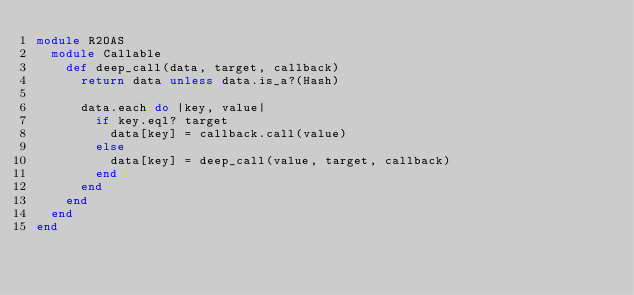Convert code to text. <code><loc_0><loc_0><loc_500><loc_500><_Ruby_>module R2OAS
  module Callable
    def deep_call(data, target, callback)
      return data unless data.is_a?(Hash)

      data.each do |key, value|
        if key.eql? target
          data[key] = callback.call(value)
        else
          data[key] = deep_call(value, target, callback)
        end
      end
    end
  end
end
</code> 